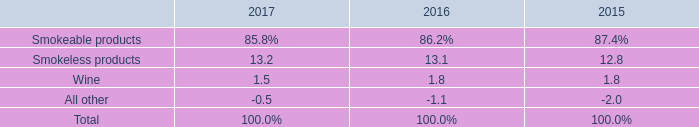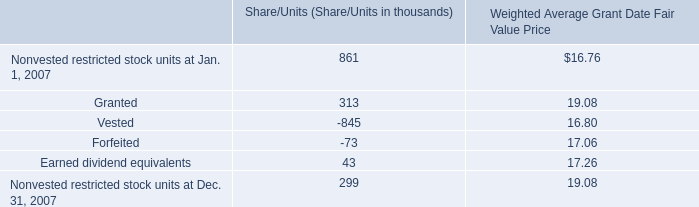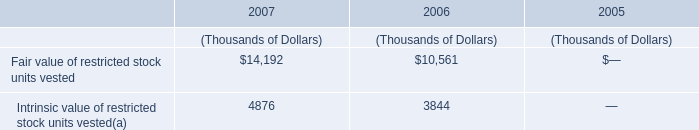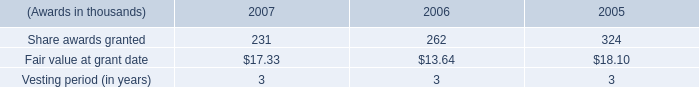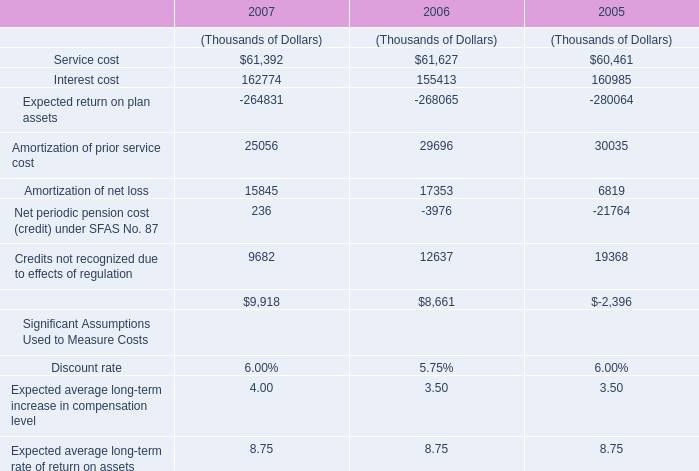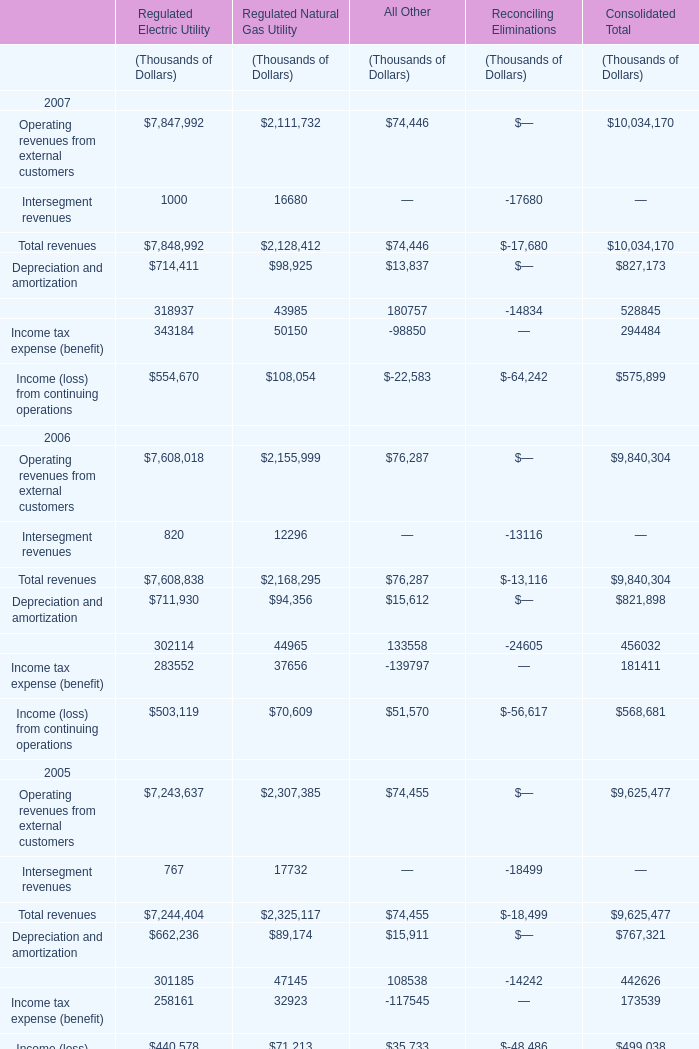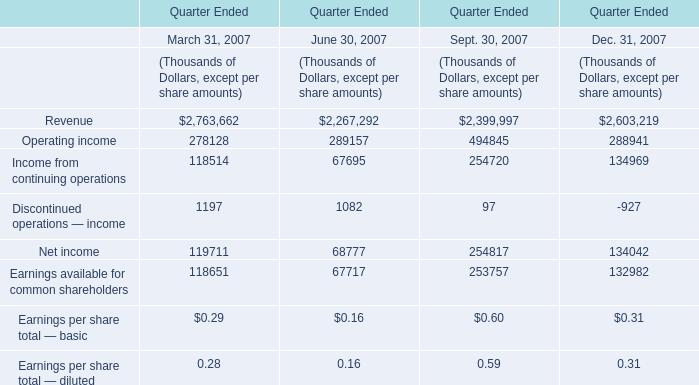In which year is the value of Depreciation and amortization for Regulated Natural Gas Utility greater than 98000 thousand? 
Answer: 2007. 